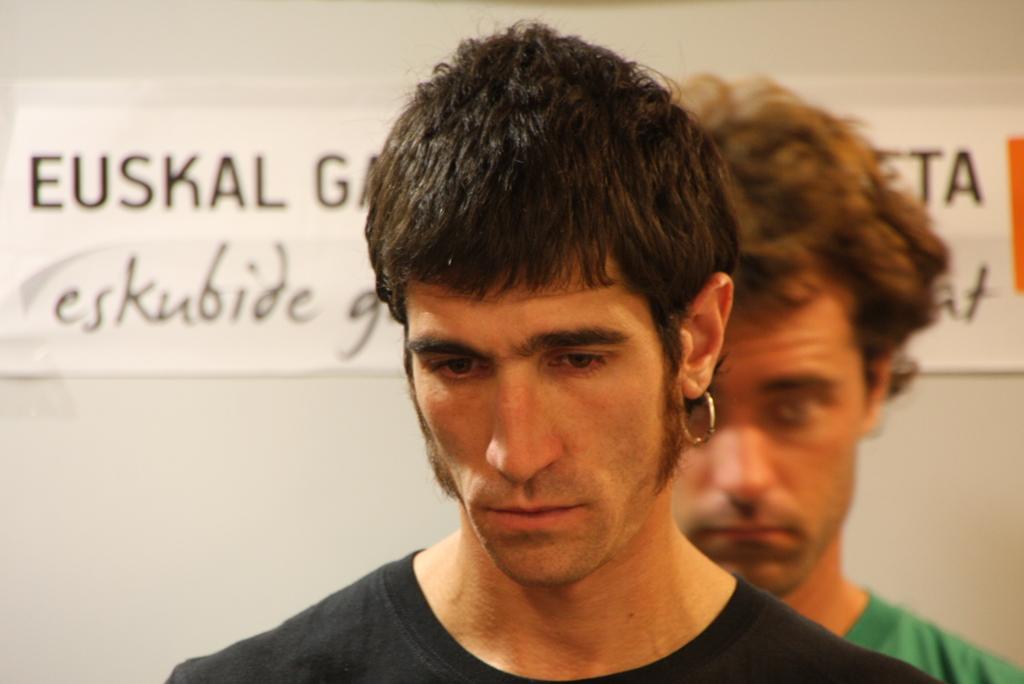Describe this image in one or two sentences. In this image we can see two persons wearing the t shirts. In the background, we can see the text papers attached to the plain wall. 